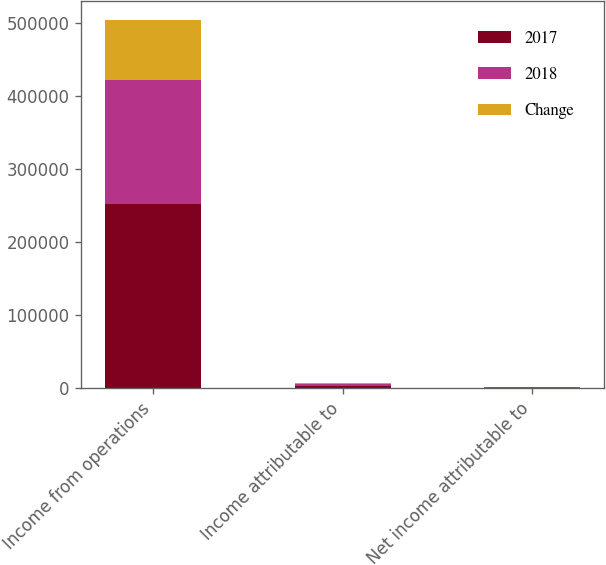Convert chart to OTSL. <chart><loc_0><loc_0><loc_500><loc_500><stacked_bar_chart><ecel><fcel>Income from operations<fcel>Income attributable to<fcel>Net income attributable to<nl><fcel>2017<fcel>252325<fcel>3198<fcel>525<nl><fcel>2018<fcel>169243<fcel>2903<fcel>388<nl><fcel>Change<fcel>83082<fcel>295<fcel>137<nl></chart> 